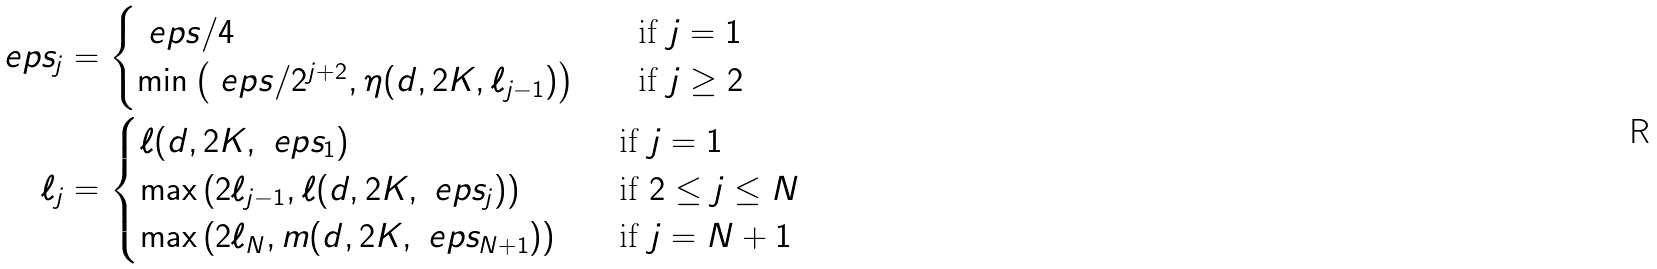Convert formula to latex. <formula><loc_0><loc_0><loc_500><loc_500>\ e p s _ { j } & = \begin{cases} \ e p s / 4 & \quad \text {if $j=1$} \\ \min \left ( \ e p s / 2 ^ { j + 2 } , \eta ( d , 2 K , \ell _ { j - 1 } ) \right ) & \quad \text {if $j\geq 2$} \end{cases} \\ \ell _ { j } & = \begin{cases} \ell ( d , 2 K , \ e p s _ { 1 } ) & \quad \text {if $j=1$} \\ \max \left ( 2 \ell _ { j - 1 } , \ell ( d , 2 K , \ e p s _ { j } ) \right ) & \quad \text {if $2\leq j \leq N$} \\ \max \left ( 2 \ell _ { N } , m ( d , 2 K , \ e p s _ { N + 1 } ) \right ) & \quad \text {if $j = N+1$} \end{cases}</formula> 